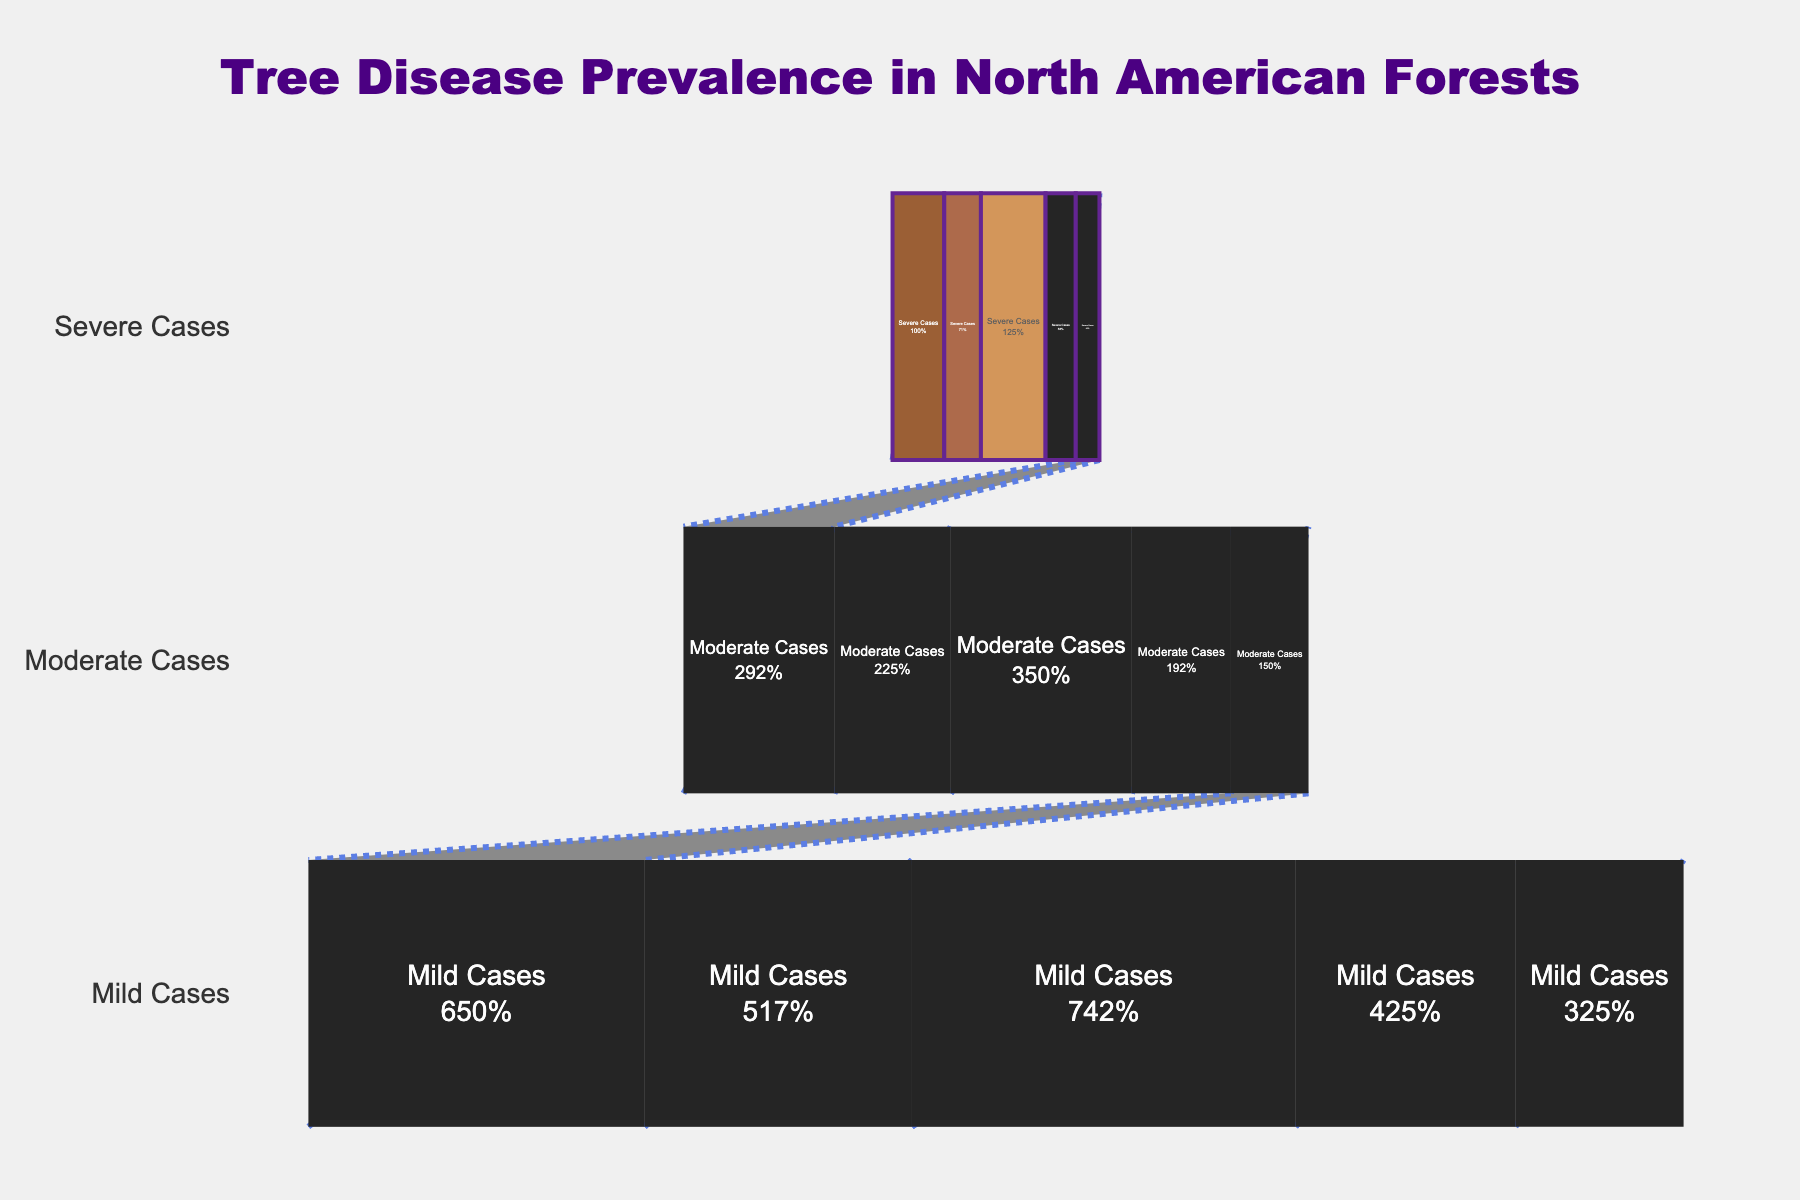What is the title of the funnel chart? The title of the funnel chart is located at the top and is presented in a larger and bolder font compared to other text elements. It reads "Tree Disease Prevalence in North American Forests".
Answer: Tree Disease Prevalence in North American Forests Which tree disease has the highest number of severe cases? Locate the segment of the funnel chart labeled "Severe Cases" and identify the tree disease with the longest bar. Pine Beetle Infestation has the highest number of severe cases.
Answer: Pine Beetle Infestation How many moderate cases are reported for Sudden Oak Death? Find the "Moderate Cases" segment in the funnel chart and locate the entry for "Sudden Oak Death". The length of the bar will indicate the number of cases, which is 27,000.
Answer: 27,000 What is the combined number of mild cases for Dutch Elm Disease and Ash Dieback? Identify the "Mild Cases" segment in the funnel chart and find the numbers for Dutch Elm Disease (78,000) and Ash Dieback (51,000). Add these numbers together: 78,000 + 51,000 = 129,000.
Answer: 129,000 Which disease has fewer severe cases: Chestnut Blight or Ash Dieback? Compare the lengths of the bars in the "Severe Cases" section for Chestnut Blight and Ash Dieback. Chestnut Blight has 5,500 severe cases while Ash Dieback has 7,000 severe cases. Therefore, Chestnut Blight has fewer severe cases.
Answer: Chestnut Blight What is the percentage of Dutch Elm Disease cases that are considered mild out of all Dutch Elm Disease cases? Given the cases for Dutch Elm Disease: Severe (12,000), Moderate (35,000), and Mild (78,000). First, sum them up: 12,000 + 35,000 + 78,000 = 125,000. Next, calculate the percentage using the number of mild cases: (78,000 / 125,000) * 100% ≈ 62.4%.
Answer: 62.4% In terms of total number of cases, which disease is ranked second? First, sum the severe, moderate, and mild cases for each disease. Dutch Elm Disease: 125,000; Sudden Oak Death: 97,500; Pine Beetle Infestation: 146,000; Ash Dieback: 80,000; Chestnut Blight: 62,000. Pine Beetle Infestation has the most cases, making Dutch Elm Disease (125,000) second.
Answer: Dutch Elm Disease 